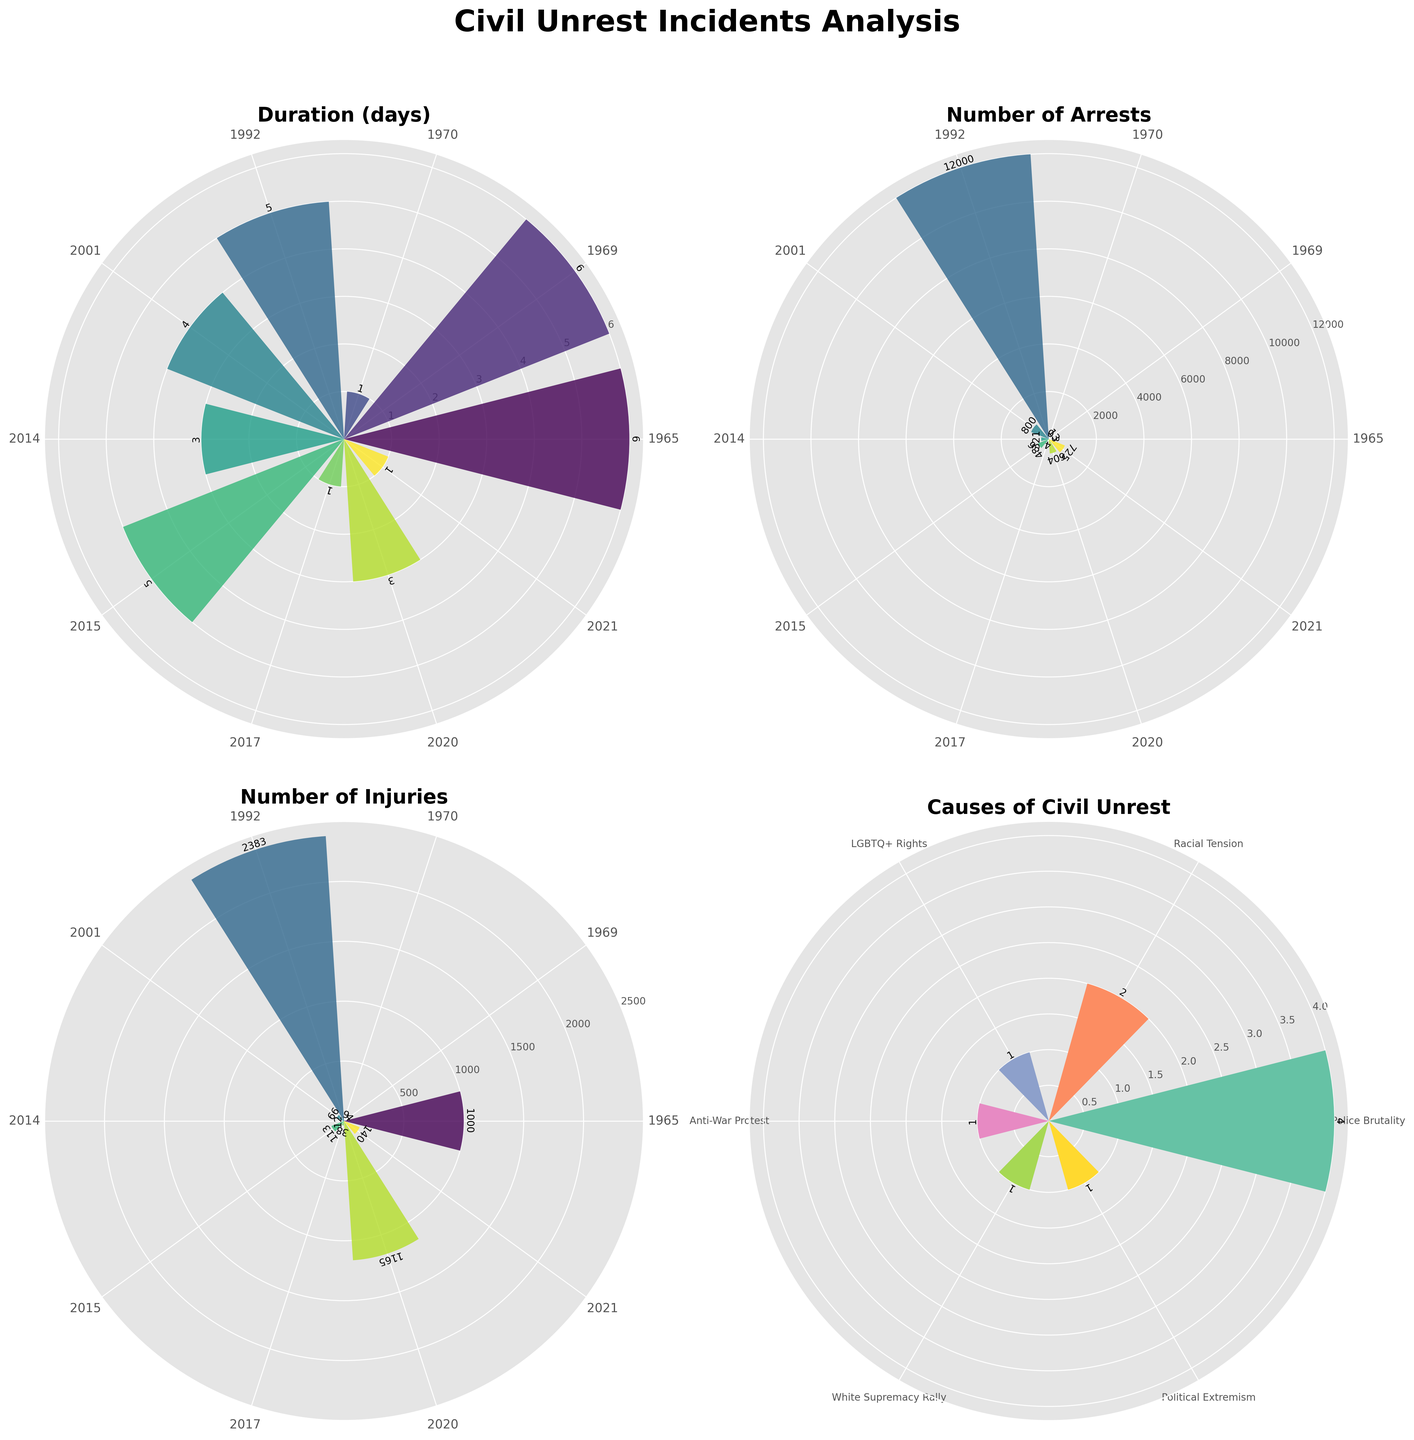What is the title of the figure? The title of the figure is usually placed at the top of the plot and is meant to provide a summary of the visual information. In this case, it is "Civil Unrest Incidents Analysis".
Answer: Civil Unrest Incidents Analysis How many metrics are plotted in the subplots? We can count the number of distinct metrics labeled within the polar charts. Here, there are three labeled metrics: "Duration (days)", "Number of Arrests", and "Number of Injuries".
Answer: Three Which year had the highest number of arrests? By looking at the bar heights in the "Number of Arrests" subplot, the year 1992 stands out with the highest value, corresponding to the Rodney King Riots.
Answer: 1992 What is the total number of incidents analyzed in the figure? By counting the number of bars present in any of the subplots, we identify there are 10 incidents analyzed.
Answer: 10 What's the total duration of all incidents? To find the total duration, sum up the duration values from the "Duration (days)" subplot. The calculation is 6 + 6 + 1 + 5 + 4 + 3 + 5 + 1 + 3 + 1 = 35 days.
Answer: 35 days Which cause of civil unrest appears most frequently? By examining the "Causes of Civil Unrest" subplot, we see which cause has the highest bar. The cause "Police Brutality" appears most frequently.
Answer: Police Brutality Which incident had the highest number of injuries and what was the number? By looking at the "Number of Injuries" subplot, the George Floyd Protests in 2020 had the highest number, with a value of 1165.
Answer: George Floyd Protests, 1165 What is the average number of injuries per incident? Adding the number of injuries for all incidents and dividing by the total number of incidents. The sum is 1000 + 4 + 9 + 2383 + 66 + 12 + 113 + 38 + 1165 + 140 = 4930 injuries; 4930 / 10 = 493 injuries per incident on average.
Answer: 493 Compare the public safety responses used in Los Angeles between 1965 and 1992. Which was more severe, considering the number of arrests? The Watts Riots in 1965 involved a National Guard Deployment with 3 arrests, while the Rodney King Riots in 1992 involved a Curfew and Police Mobilization with 12000 arrests. Hence, the response in 1992 was more severe in terms of arrests.
Answer: 1992 Which incidents lasted for exactly 1 day? By looking at the "Duration (days)" subplot, the Kent State Shooting (1970), Charlottesville Rally (2017), and Capitol Riot (2021) lasted for exactly 1 day.
Answer: Kent State Shooting, Charlottesville Rally, Capitol Riot 